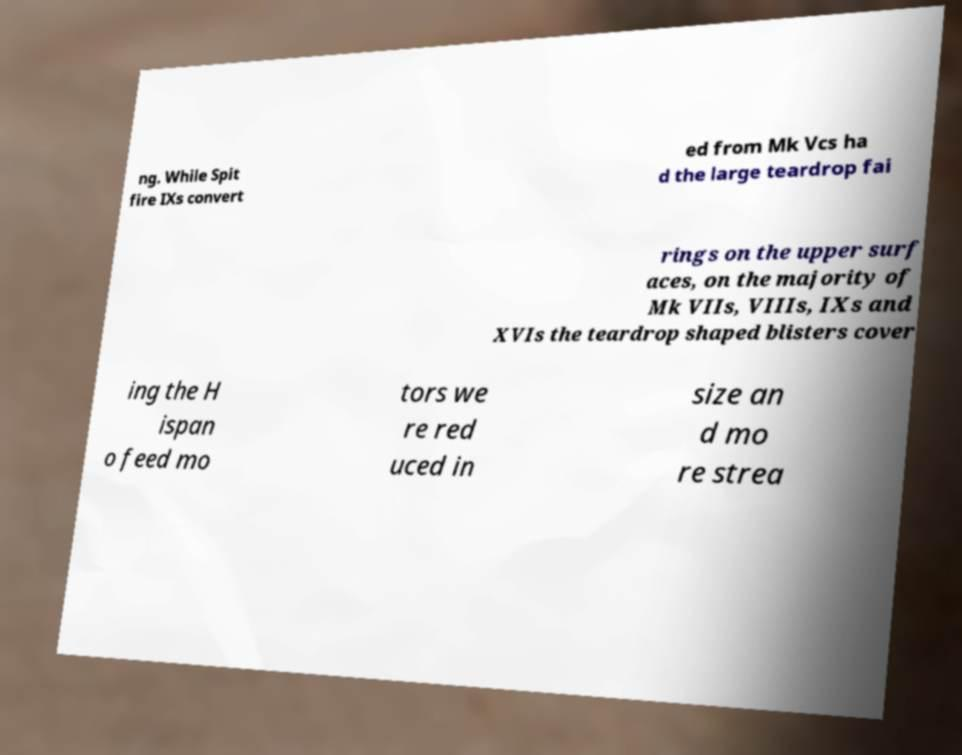What messages or text are displayed in this image? I need them in a readable, typed format. ng. While Spit fire IXs convert ed from Mk Vcs ha d the large teardrop fai rings on the upper surf aces, on the majority of Mk VIIs, VIIIs, IXs and XVIs the teardrop shaped blisters cover ing the H ispan o feed mo tors we re red uced in size an d mo re strea 